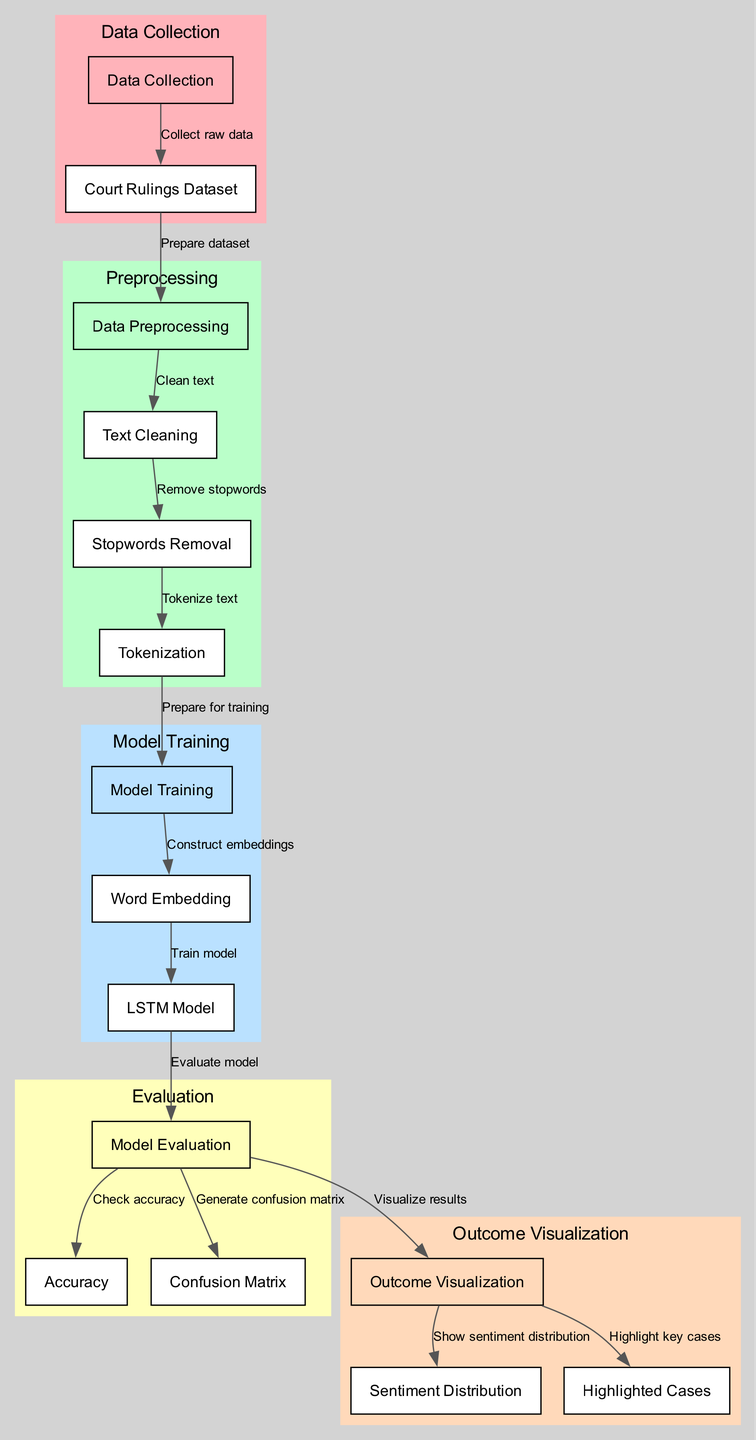What are the main stages in the workflow? The workflow consists of five main stages: Data Collection, Preprocessing, Model Training, Evaluation, and Outcome Visualization. Each of these stages contains specific tasks that are crucial for the sentiment analysis.
Answer: Data Collection, Preprocessing, Model Training, Evaluation, Outcome Visualization How many edges are present in the diagram? The diagram shows a total of 13 edges, which represent the relationships and flow of data between the various nodes in the workflow.
Answer: 13 What node follows ‘Text Cleaning’? ‘Stopwords Removal’ directly follows ‘Text Cleaning’, indicating that after the text is cleaned, unnecessary words (stopwords) are removed to prepare it for further analysis.
Answer: Stopwords Removal Which model is used for training? The model used for training in this workflow is the ‘LSTM Model’, which is a specialized type of neural network for processing sequences, making it suitable for textual data.
Answer: LSTM Model What is analyzed during the Evaluation stage? The Evaluation stage analyzes both the ‘Accuracy’ of the model and generates a ‘Confusion Matrix’, which helps in assessing the model's performance against the test dataset.
Answer: Accuracy, Confusion Matrix What is depicted in ‘Outcome Visualization’? The ‘Outcome Visualization’ stage shows both the ‘Sentiment Distribution’ of the analyzed court rulings and ‘Highlighted Cases’ that may have significant relevance or impact on human rights issues.
Answer: Sentiment Distribution, Highlighted Cases What is the first step of data processing? The first step of data processing is ‘Text Cleaning’, which involves removing any unwanted characters and formatting issues to prepare the text for further stages.
Answer: Text Cleaning How does the diagram illustrate the flow from court rulings to preprocessing? The flow from ‘Court Rulings Dataset’ to ‘Preprocessing’ is depicted by an edge labeled ‘Prepare dataset’, indicating that the raw data collected from court rulings is prepared before any specific processing is done.
Answer: Prepare dataset 